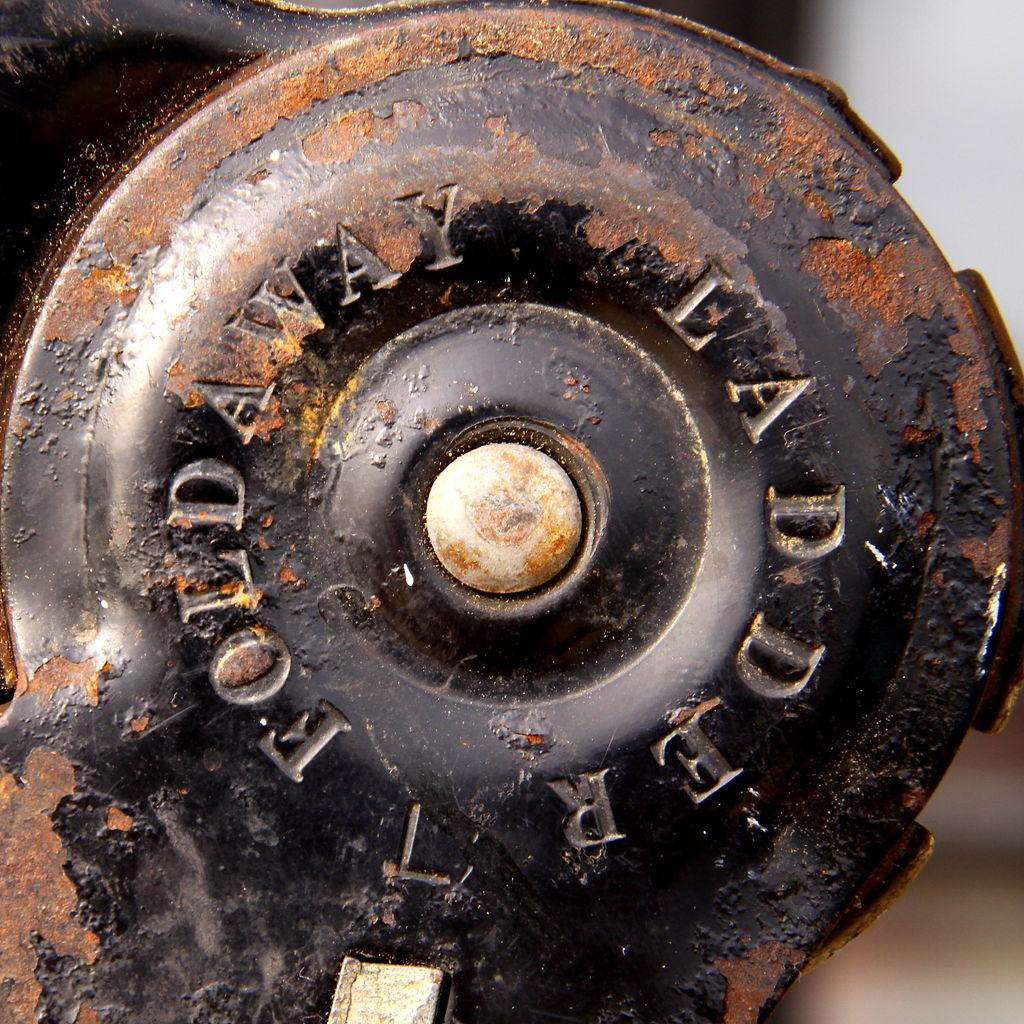What type of object can be seen in the image? There is a rusted iron object in the image. Can you describe the background of the image? The background of the image is blurred. What type of quartz is present in the image? There is no quartz present in the image; it features a rusted iron object and a blurred background. 